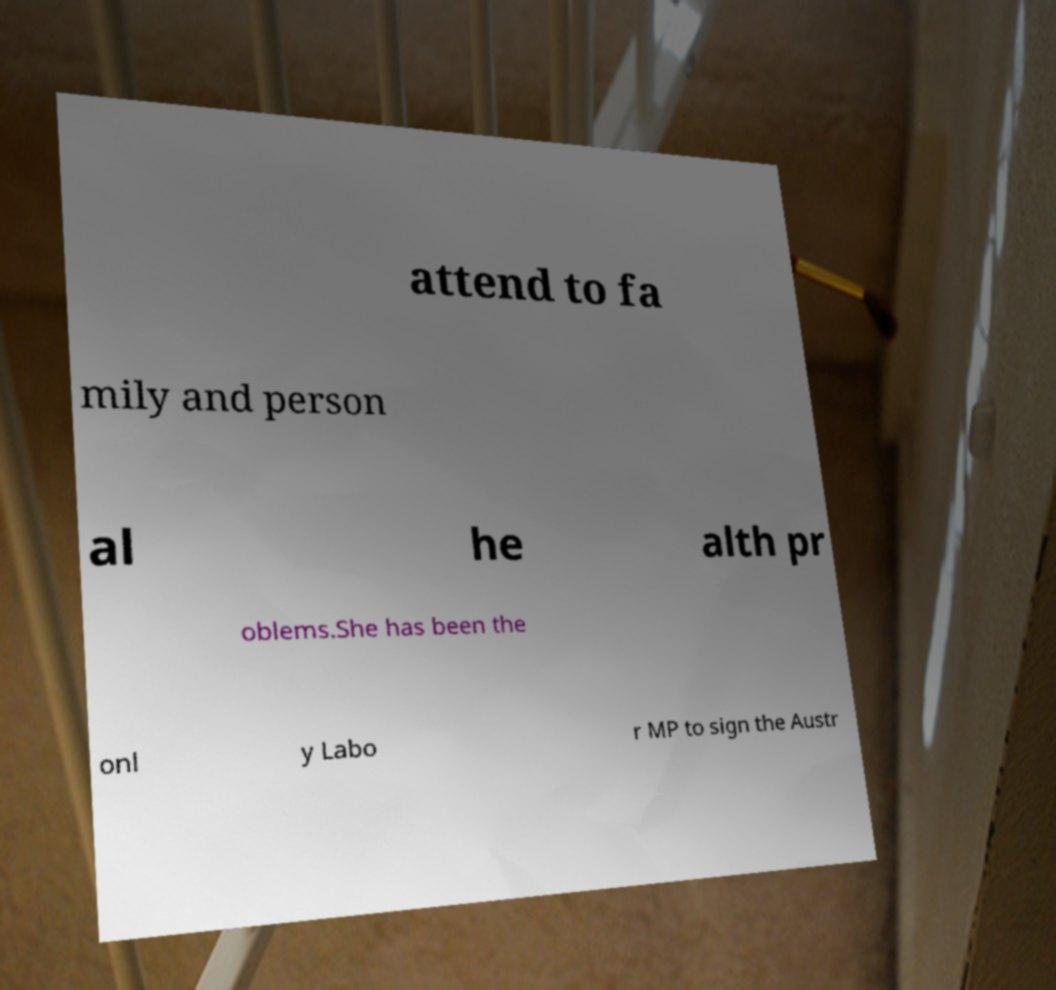Could you extract and type out the text from this image? attend to fa mily and person al he alth pr oblems.She has been the onl y Labo r MP to sign the Austr 